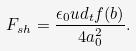Convert formula to latex. <formula><loc_0><loc_0><loc_500><loc_500>F _ { s h } = \frac { \epsilon _ { 0 } u d _ { t } f ( b ) } { 4 a _ { 0 } ^ { 2 } } .</formula> 